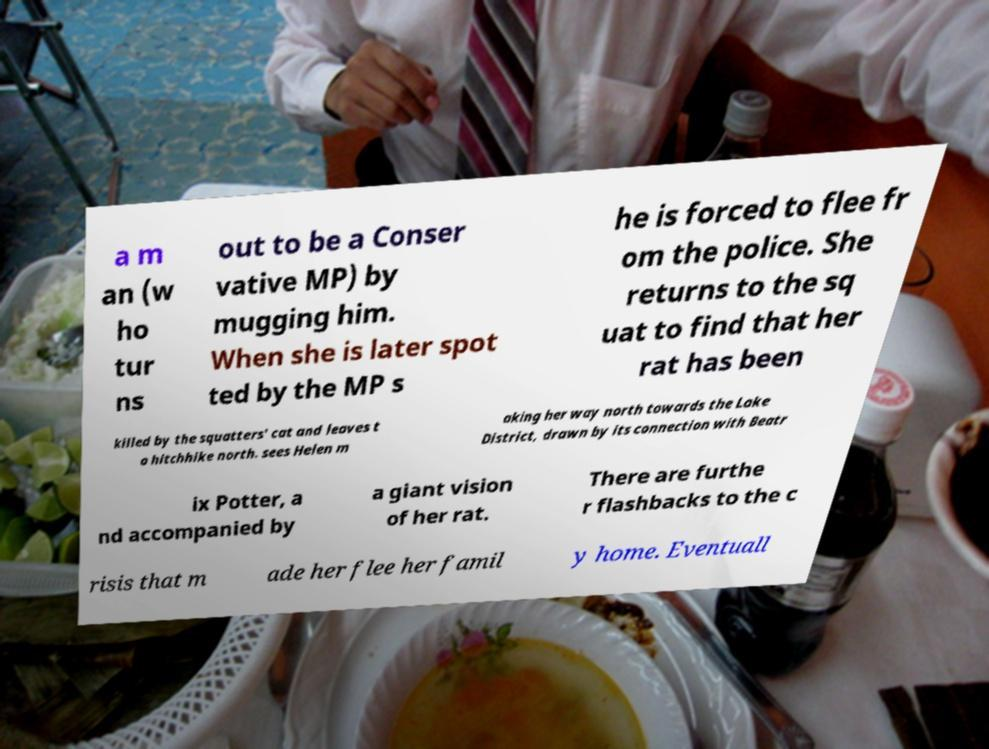I need the written content from this picture converted into text. Can you do that? a m an (w ho tur ns out to be a Conser vative MP) by mugging him. When she is later spot ted by the MP s he is forced to flee fr om the police. She returns to the sq uat to find that her rat has been killed by the squatters' cat and leaves t o hitchhike north. sees Helen m aking her way north towards the Lake District, drawn by its connection with Beatr ix Potter, a nd accompanied by a giant vision of her rat. There are furthe r flashbacks to the c risis that m ade her flee her famil y home. Eventuall 